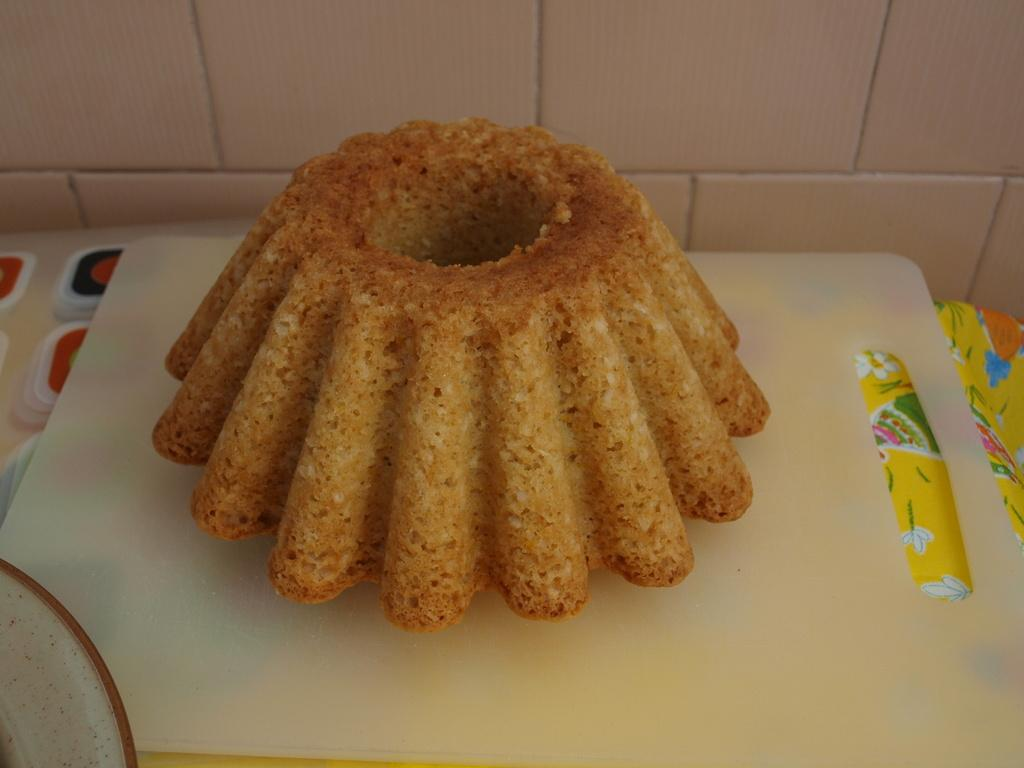What type of food can be seen in the image? The food in the image is brown in color. What is the color of the board on which the food is placed? The food is on a white color board. What can be seen in the background of the image? The background of the image includes a white wall. How many people are in the crowd behind the food in the image? There is no crowd present in the image; it only features the brown food on a white color board with a white wall in the background. 